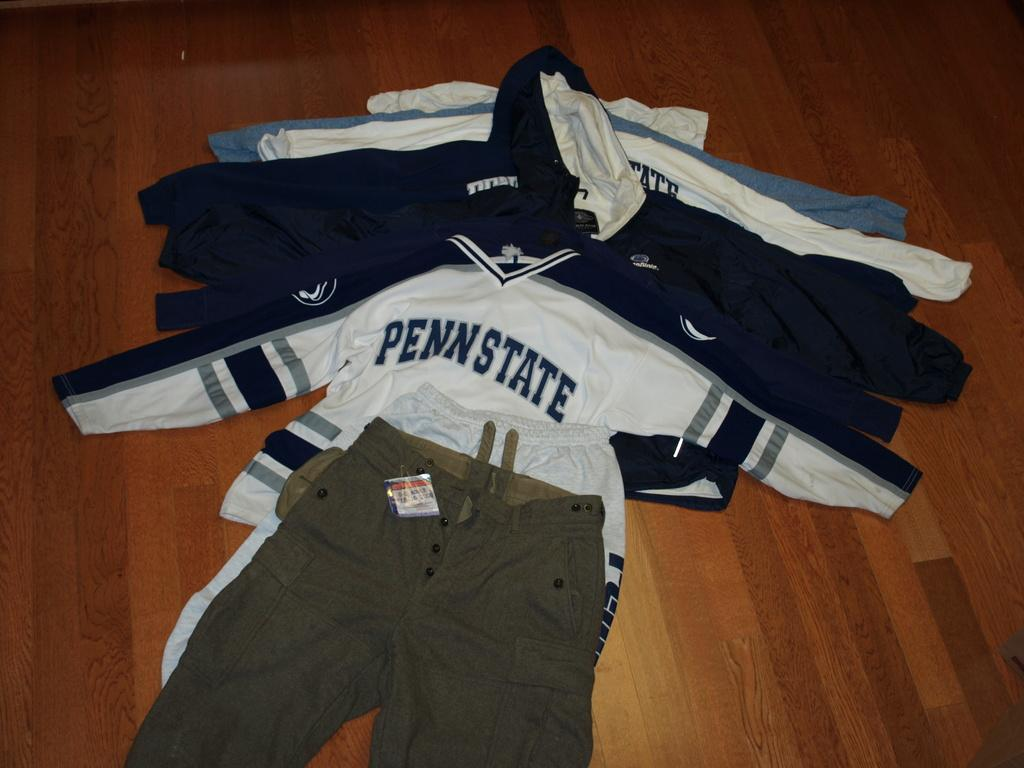<image>
Summarize the visual content of the image. A stack of clothing with a Penn State shirt on top. 